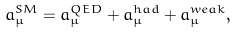<formula> <loc_0><loc_0><loc_500><loc_500>a _ { \mu } ^ { S M } = a _ { \mu } ^ { Q E D } + a _ { \mu } ^ { h a d } + a _ { \mu } ^ { w e a k } ,</formula> 